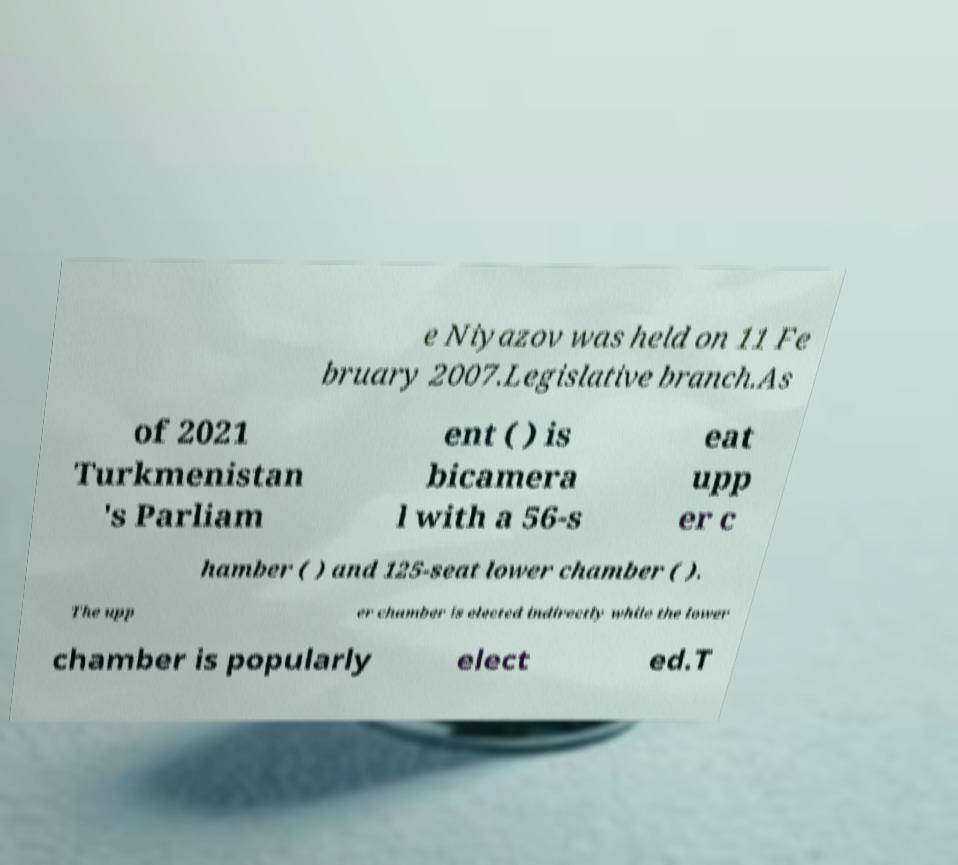I need the written content from this picture converted into text. Can you do that? e Niyazov was held on 11 Fe bruary 2007.Legislative branch.As of 2021 Turkmenistan 's Parliam ent ( ) is bicamera l with a 56-s eat upp er c hamber ( ) and 125-seat lower chamber ( ). The upp er chamber is elected indirectly while the lower chamber is popularly elect ed.T 